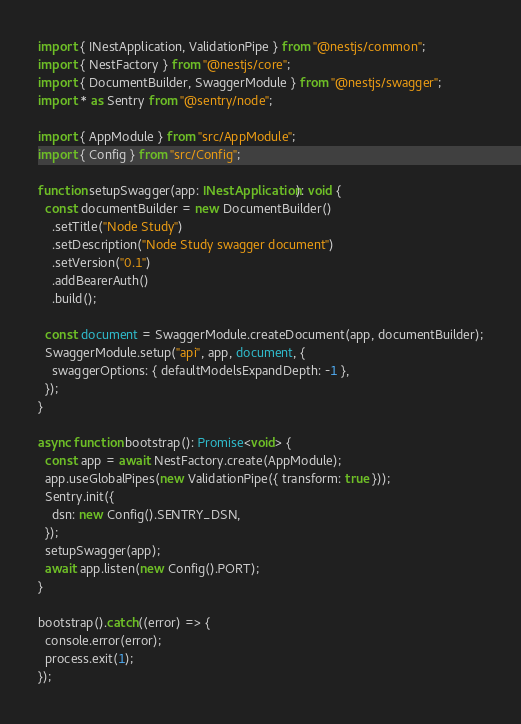Convert code to text. <code><loc_0><loc_0><loc_500><loc_500><_TypeScript_>import { INestApplication, ValidationPipe } from "@nestjs/common";
import { NestFactory } from "@nestjs/core";
import { DocumentBuilder, SwaggerModule } from "@nestjs/swagger";
import * as Sentry from "@sentry/node";

import { AppModule } from "src/AppModule";
import { Config } from "src/Config";

function setupSwagger(app: INestApplication): void {
  const documentBuilder = new DocumentBuilder()
    .setTitle("Node Study")
    .setDescription("Node Study swagger document")
    .setVersion("0.1")
    .addBearerAuth()
    .build();

  const document = SwaggerModule.createDocument(app, documentBuilder);
  SwaggerModule.setup("api", app, document, {
    swaggerOptions: { defaultModelsExpandDepth: -1 },
  });
}

async function bootstrap(): Promise<void> {
  const app = await NestFactory.create(AppModule);
  app.useGlobalPipes(new ValidationPipe({ transform: true }));
  Sentry.init({
    dsn: new Config().SENTRY_DSN,
  });
  setupSwagger(app);
  await app.listen(new Config().PORT);
}

bootstrap().catch((error) => {
  console.error(error);
  process.exit(1);
});
</code> 